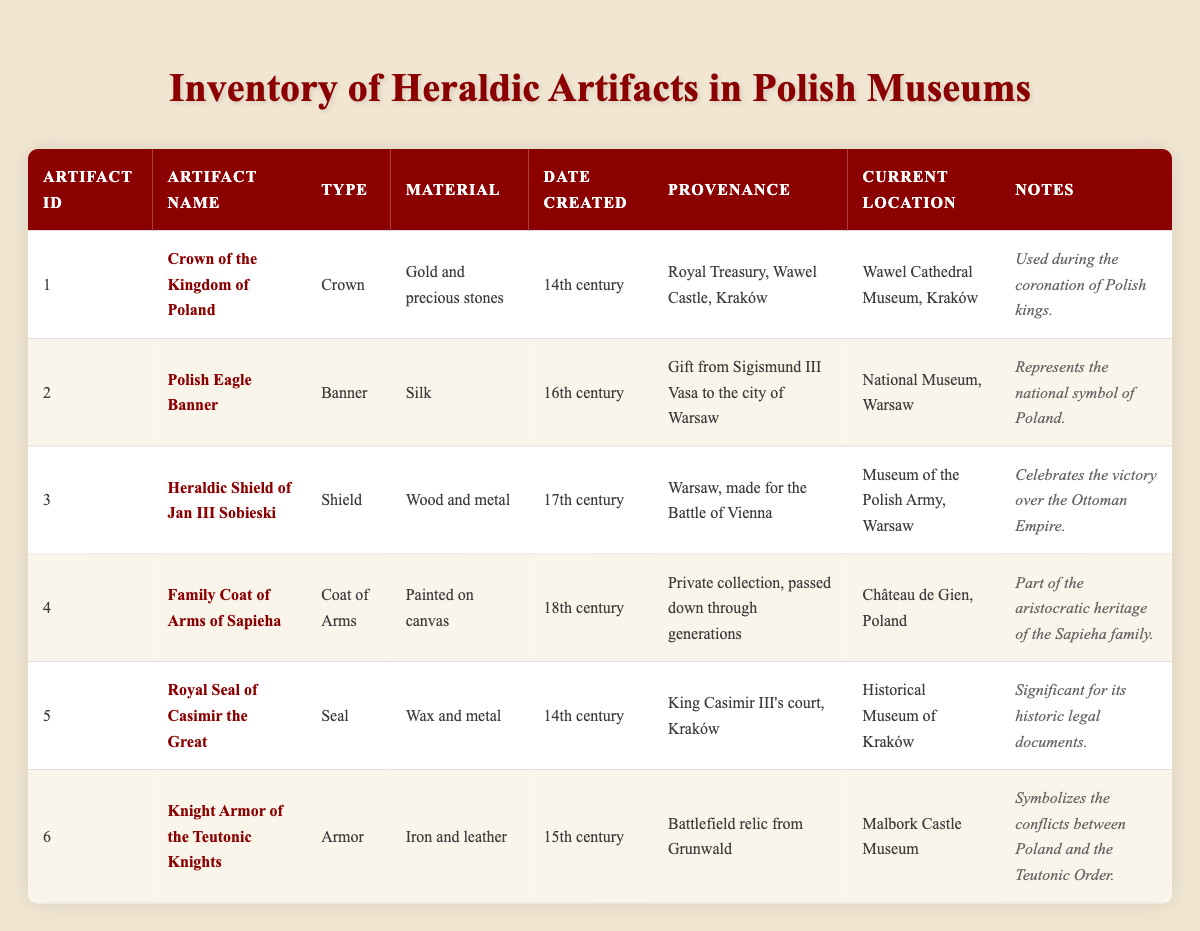What is the current location of the Crown of the Kingdom of Poland? The table lists the current location of the Crown of the Kingdom of Poland in the row corresponding to its artifact ID. It states that this artifact is located at the Wawel Cathedral Museum in Kraków.
Answer: Wawel Cathedral Museum, Kraków Which artifact was made in the 15th century? Looking through the table, I identify the artifacts by their date created. The Knight Armor of the Teutonic Knights is the only one listed with a date created in the 15th century.
Answer: Knight Armor of the Teutonic Knights Is the Polish Eagle Banner made of silk? The table directly states the material of the Polish Eagle Banner in the row with artifact ID 2. It confirms that the Polish Eagle Banner is indeed made of silk.
Answer: Yes How many artifacts were created in the 14th century? To find the count of artifacts created in the 14th century, I review the table and note the artifacts with that date. The Crown of the Kingdom of Poland and the Royal Seal of Casimir the Great were both created in the 14th century, totaling two artifacts.
Answer: 2 What type of artifact has the notes mentioning the victory over the Ottoman Empire? The notes column provides insights into the significance of the artifacts. The artifact with the notes referring to the victory over the Ottoman Empire is the Heraldic Shield of Jan III Sobieski, as indicated in the corresponding row.
Answer: Heraldic Shield of Jan III Sobieski Which artifact's provenance indicates it was a gift from Sigismund III Vasa? By examining the provenance information in the table, it becomes clear that the Polish Eagle Banner is the artifact that notes it was a gift from Sigismund III Vasa to the city of Warsaw.
Answer: Polish Eagle Banner How many artifacts are located in Kraków based on the current location? Reviewing the current location column, I find that two artifacts are listed with a current location in Kraków: the Crown of the Kingdom of Poland and the Royal Seal of Casimir the Great. Therefore, there are two artifacts located in Kraków.
Answer: 2 Does the Family Coat of Arms of Sapieha belong to a public or a private collection? The provenance of the Family Coat of Arms of Sapieha indicates that it belongs to a private collection, as it states it has been passed down through generations.
Answer: Private collection Which artifact combines materials of wax and metal? In the material column of the table, the Royal Seal of Casimir the Great is noted as being made from wax and metal. I confirm it by locating the relevant row corresponding to this artifact.
Answer: Royal Seal of Casimir the Great 